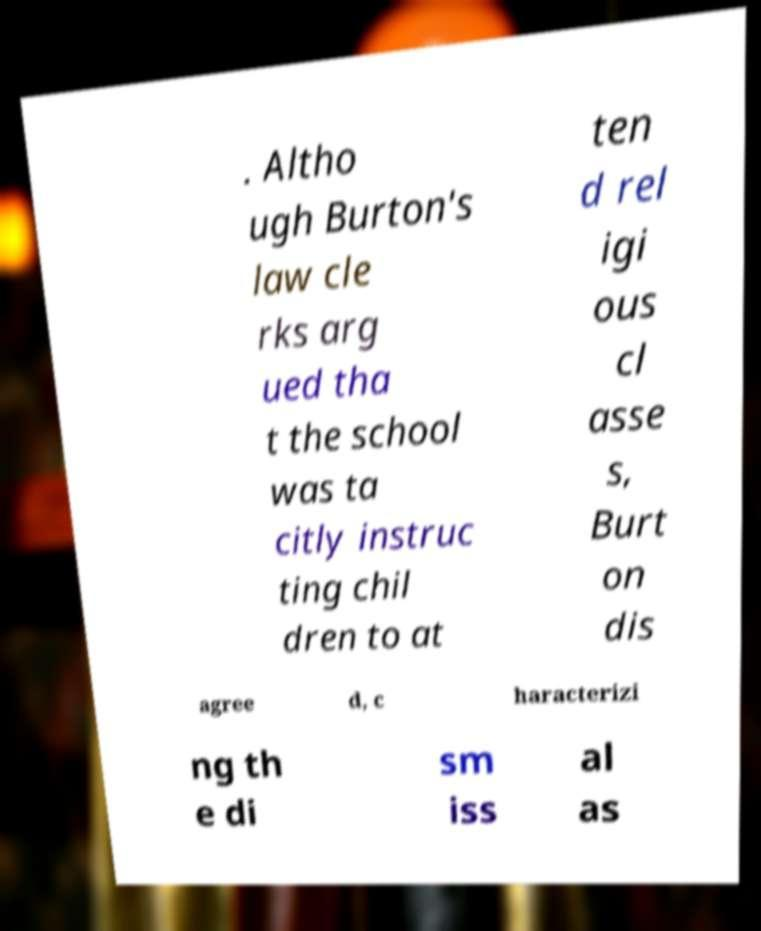I need the written content from this picture converted into text. Can you do that? . Altho ugh Burton's law cle rks arg ued tha t the school was ta citly instruc ting chil dren to at ten d rel igi ous cl asse s, Burt on dis agree d, c haracterizi ng th e di sm iss al as 